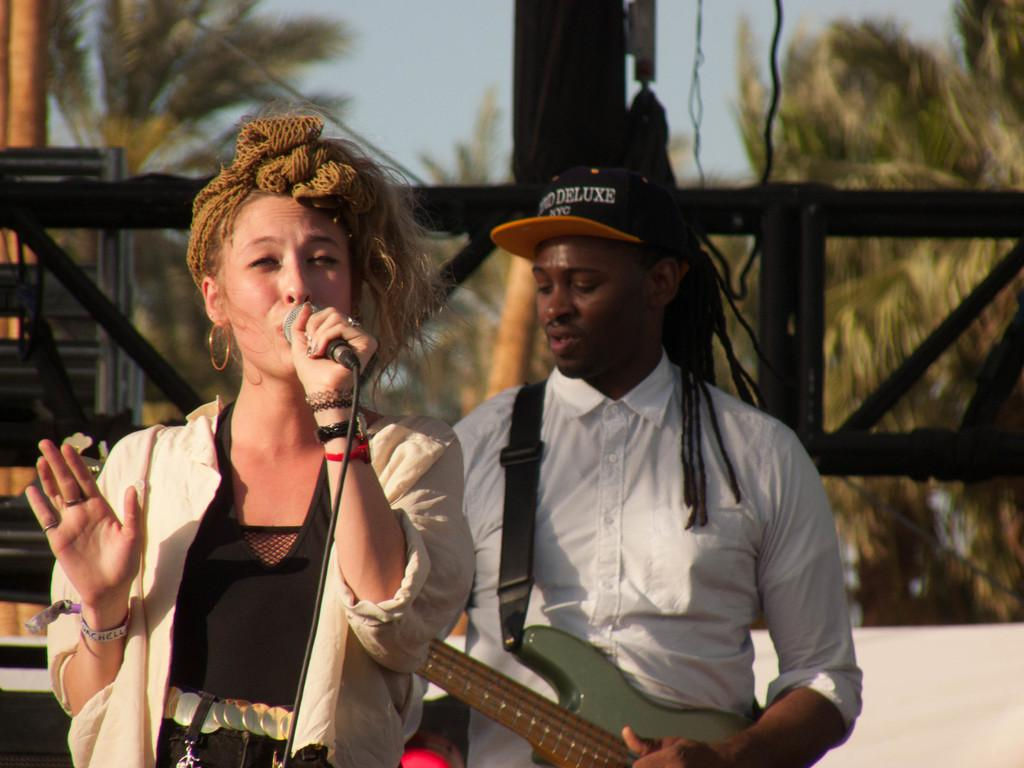What is the woman in the image doing? The woman is singing in the image. What object is the woman holding while singing? The woman is holding a microphone. What instrument is being played by the person in the image? There is a person in the image playing a guitar. What can be seen in the background of the image? Trees and the sky are visible in the background of the image. What type of punishment is being administered to the trees in the background? There is no punishment being administered to the trees in the background; they are simply visible in the image. 